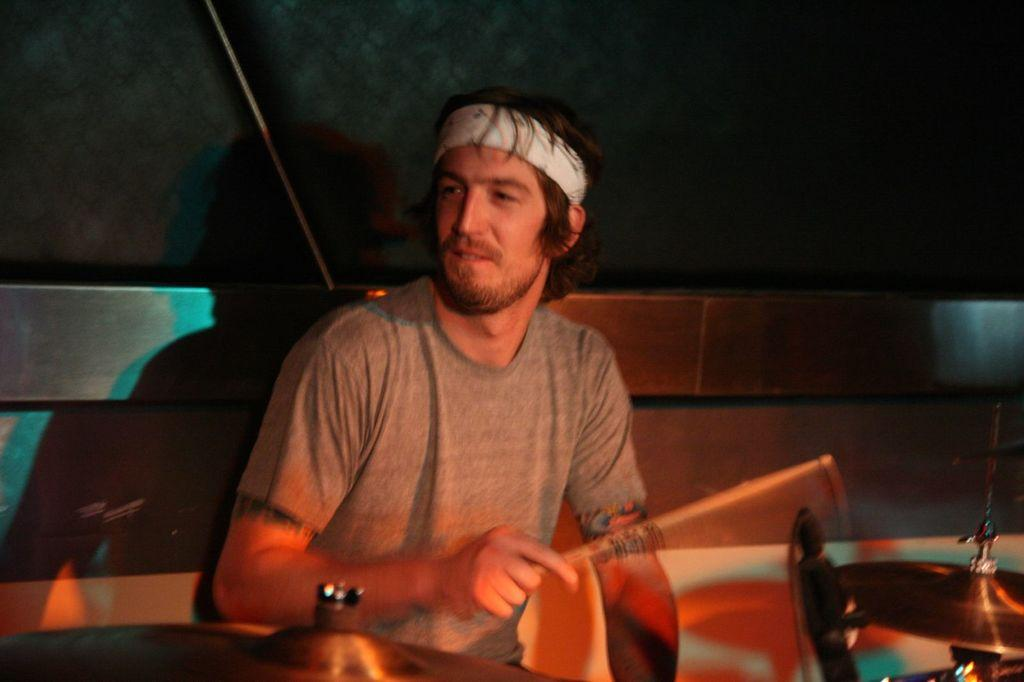What is the overall lighting condition in the image? The image is dark. Can you describe the person in the image? There is a man in the image. What is the man wearing? The man is wearing a t-shirt. What is the man doing in the image? We start by identifying the overall lighting condition of the image, which is dark. Then, we focus on the person in the image, describing their appearance and actions. We mention that the man is wearing a t-shirt and is sitting. Additionally, we note that he is playing the drums and looking at the left side. Each question is designed to elicit a specific detail about the image that is known from the provided facts. Absurd Question/Answer: Can you see the baby smiling in the crib in the image? There is no baby or crib present in the image. What statement is the man making while playing the drums in the image? There is no indication of any statement being made in the image, as it only shows a man playing the drums while sitting and looking at the left side. 